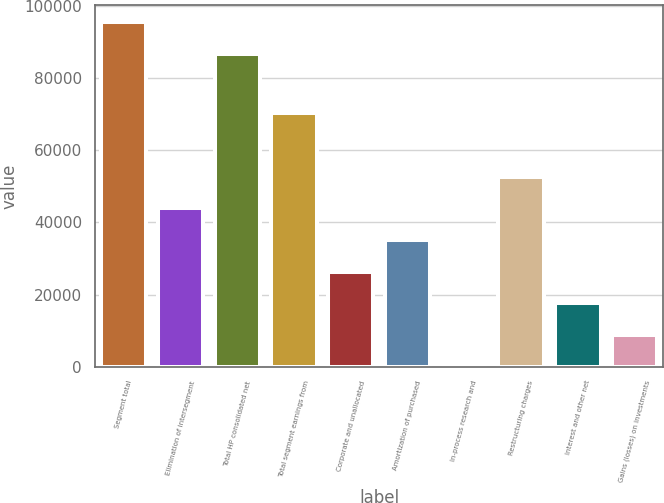Convert chart to OTSL. <chart><loc_0><loc_0><loc_500><loc_500><bar_chart><fcel>Segment total<fcel>Elimination of intersegment<fcel>Total HP consolidated net<fcel>Total segment earnings from<fcel>Corporate and unallocated<fcel>Amortization of purchased<fcel>In-process research and<fcel>Restructuring charges<fcel>Interest and other net<fcel>Gains (losses) on investments<nl><fcel>95479.3<fcel>43918.5<fcel>86696<fcel>70268.4<fcel>26351.9<fcel>35135.2<fcel>2<fcel>52701.8<fcel>17568.6<fcel>8785.3<nl></chart> 